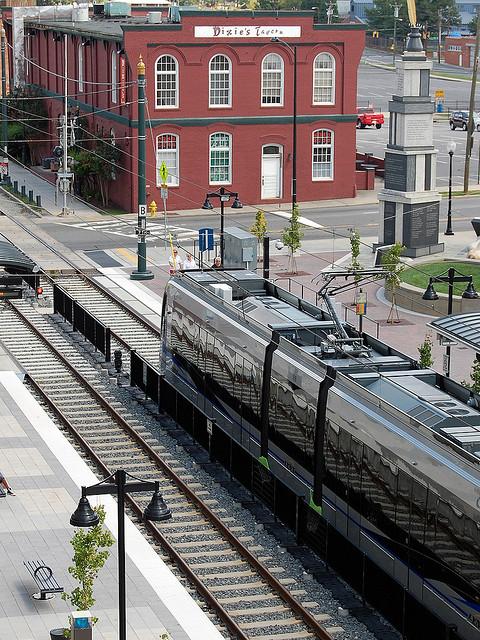What is on the tracks?
Be succinct. Train. Is this a park?
Quick response, please. No. Is the train at least somewhat reflective?
Concise answer only. Yes. Are there words written on the train?
Be succinct. No. How many train tracks?
Be succinct. 2. 